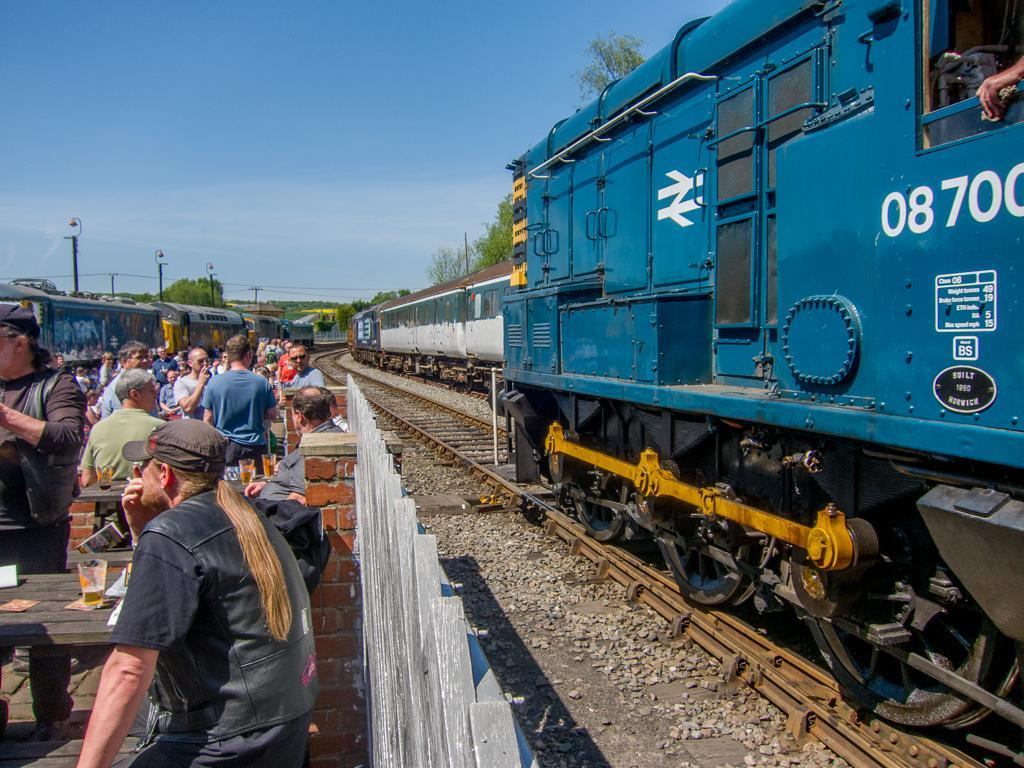<image>
Share a concise interpretation of the image provided. Many people stand by railroad tracks next to a blue engine with the identifier 08700 on it. 